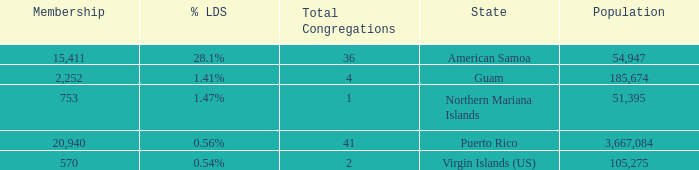What is Population, when Total Congregations is less than 4, and when % LDS is 0.54%? 105275.0. 